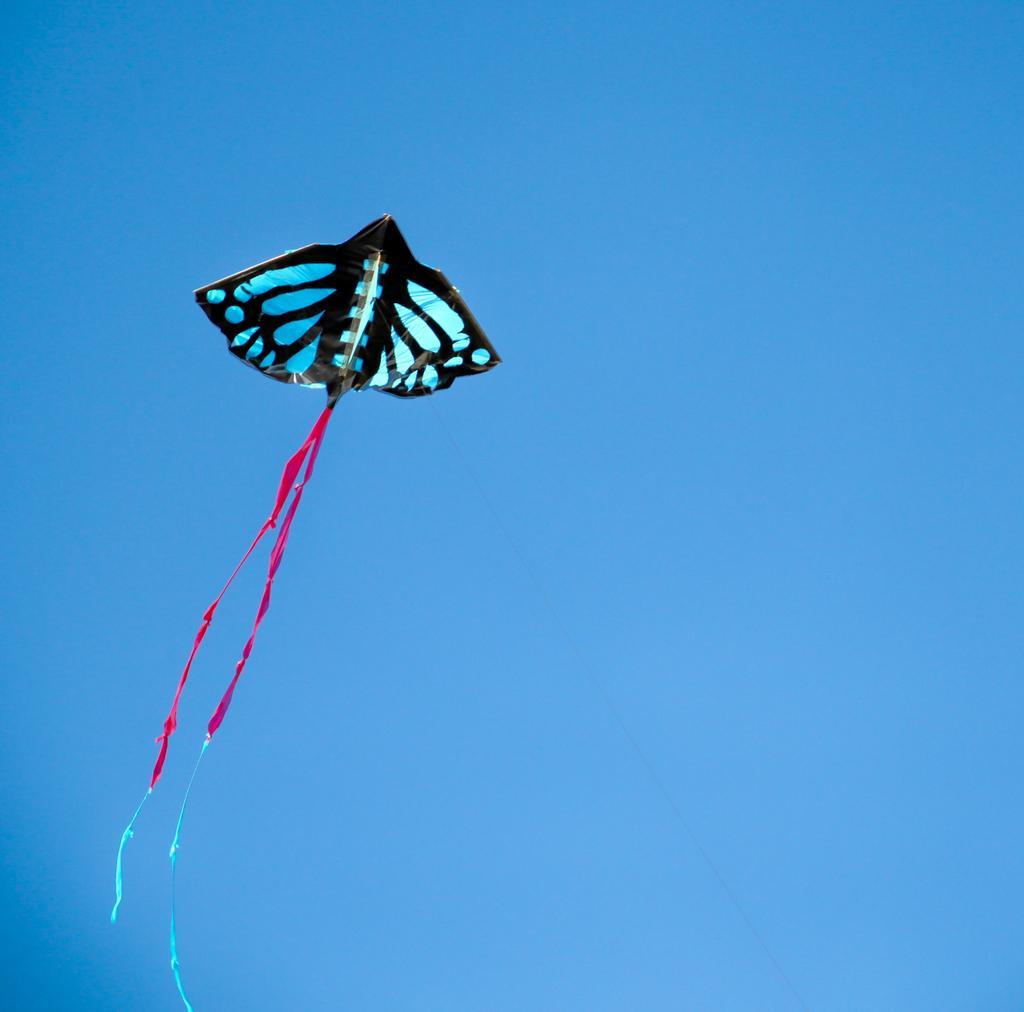Can you describe this image briefly? In the center of the image, we can see a kite in the sky. 